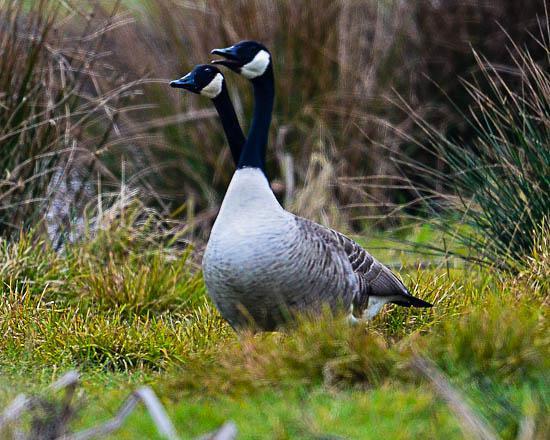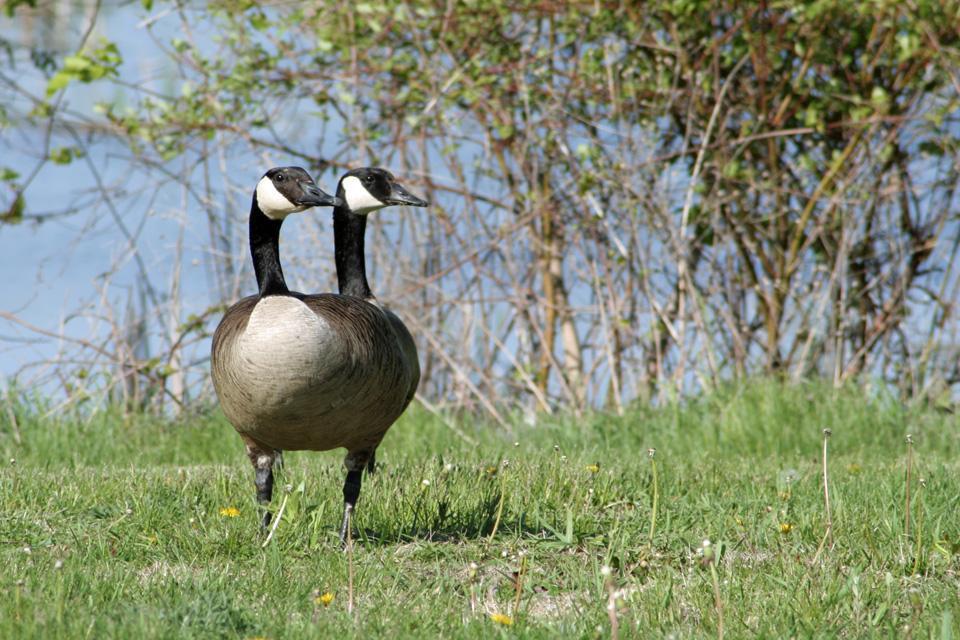The first image is the image on the left, the second image is the image on the right. For the images shown, is this caption "there are 2 geese with black and white heads standing on the grass with their shadow next to them" true? Answer yes or no. Yes. The first image is the image on the left, the second image is the image on the right. Assess this claim about the two images: "The left image shows two geese standing with bodies overlapping and upright heads close together and facing left.". Correct or not? Answer yes or no. Yes. 